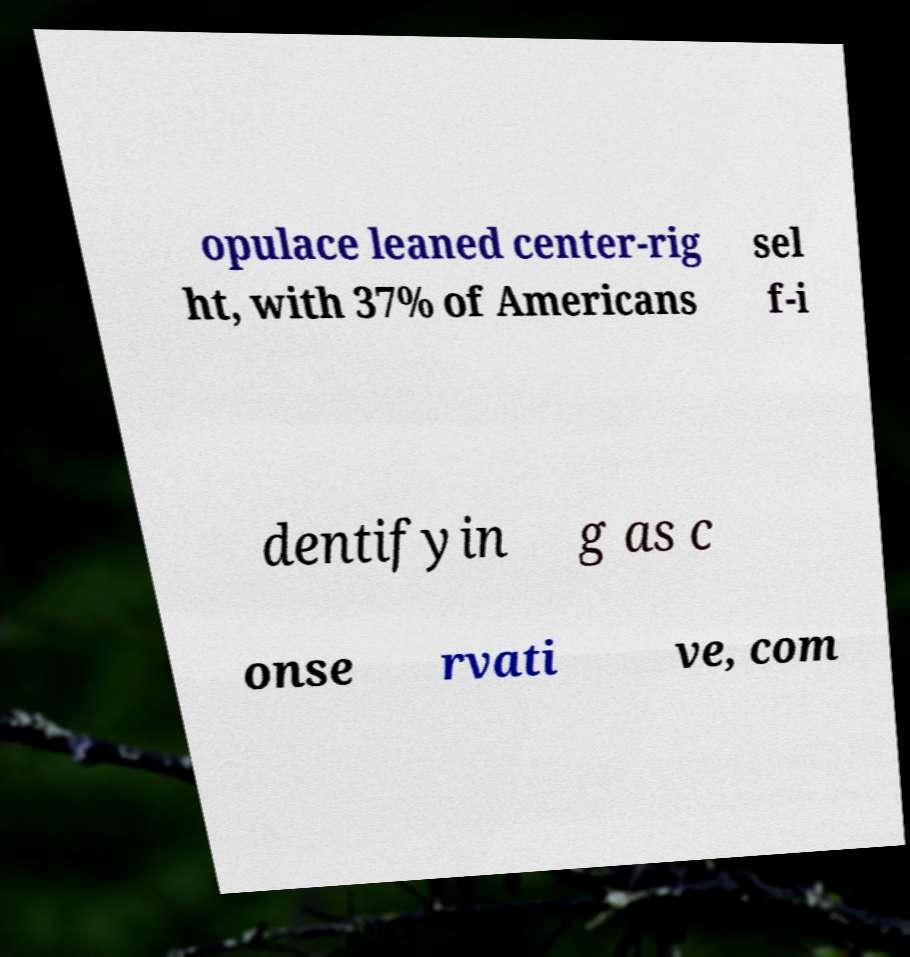There's text embedded in this image that I need extracted. Can you transcribe it verbatim? opulace leaned center-rig ht, with 37% of Americans sel f-i dentifyin g as c onse rvati ve, com 